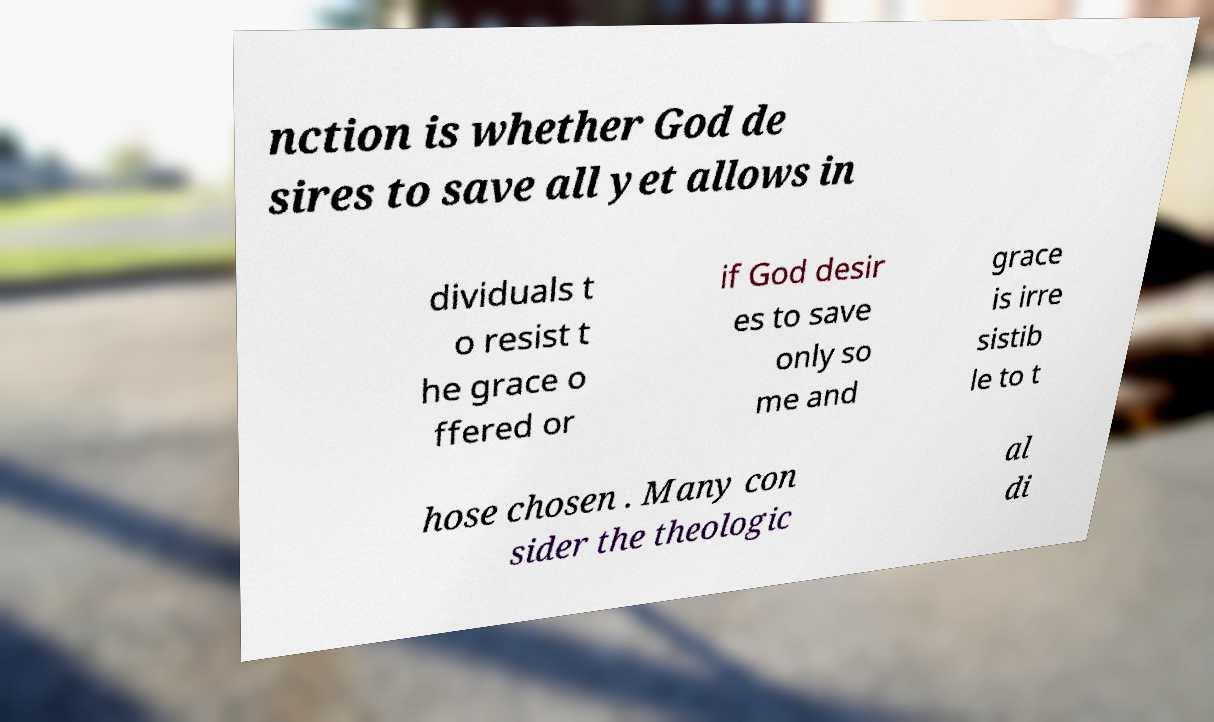Can you read and provide the text displayed in the image?This photo seems to have some interesting text. Can you extract and type it out for me? nction is whether God de sires to save all yet allows in dividuals t o resist t he grace o ffered or if God desir es to save only so me and grace is irre sistib le to t hose chosen . Many con sider the theologic al di 